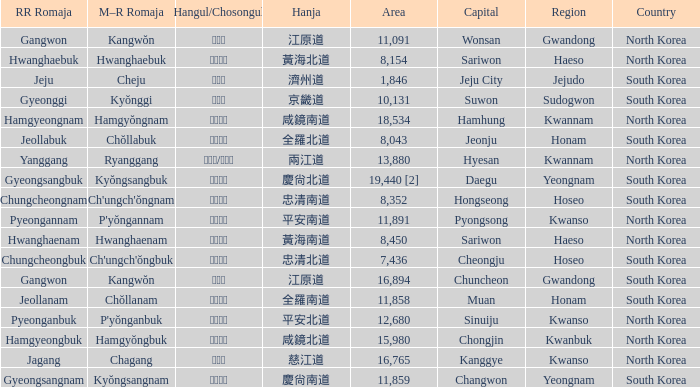Which capital has a Hangul of 경상남도? Changwon. 